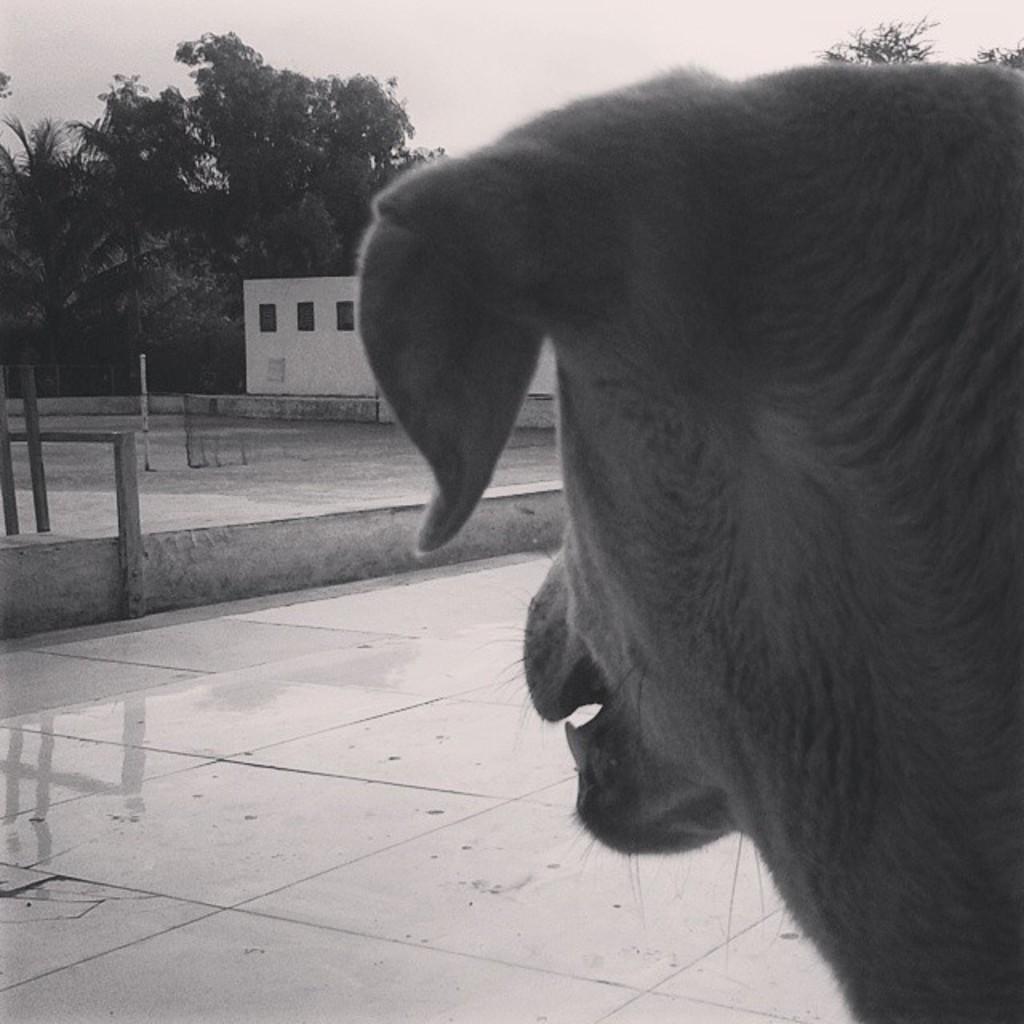How would you summarize this image in a sentence or two? In this image I can see an animal on the road. In-front of the animal I can see the house, many trees and I can this is a black and white image. 